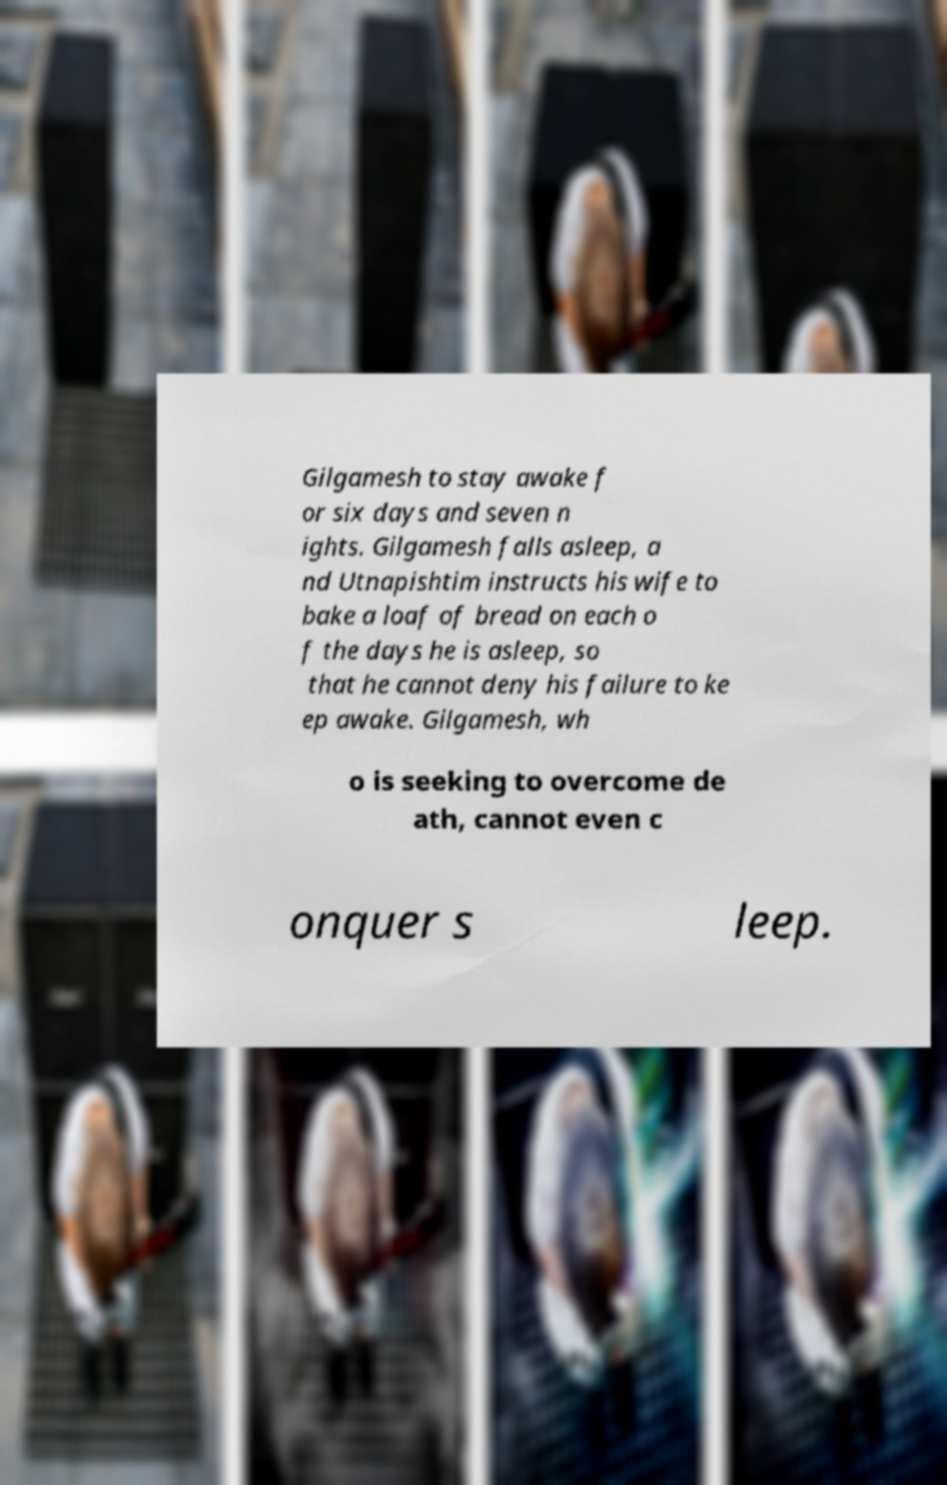For documentation purposes, I need the text within this image transcribed. Could you provide that? Gilgamesh to stay awake f or six days and seven n ights. Gilgamesh falls asleep, a nd Utnapishtim instructs his wife to bake a loaf of bread on each o f the days he is asleep, so that he cannot deny his failure to ke ep awake. Gilgamesh, wh o is seeking to overcome de ath, cannot even c onquer s leep. 